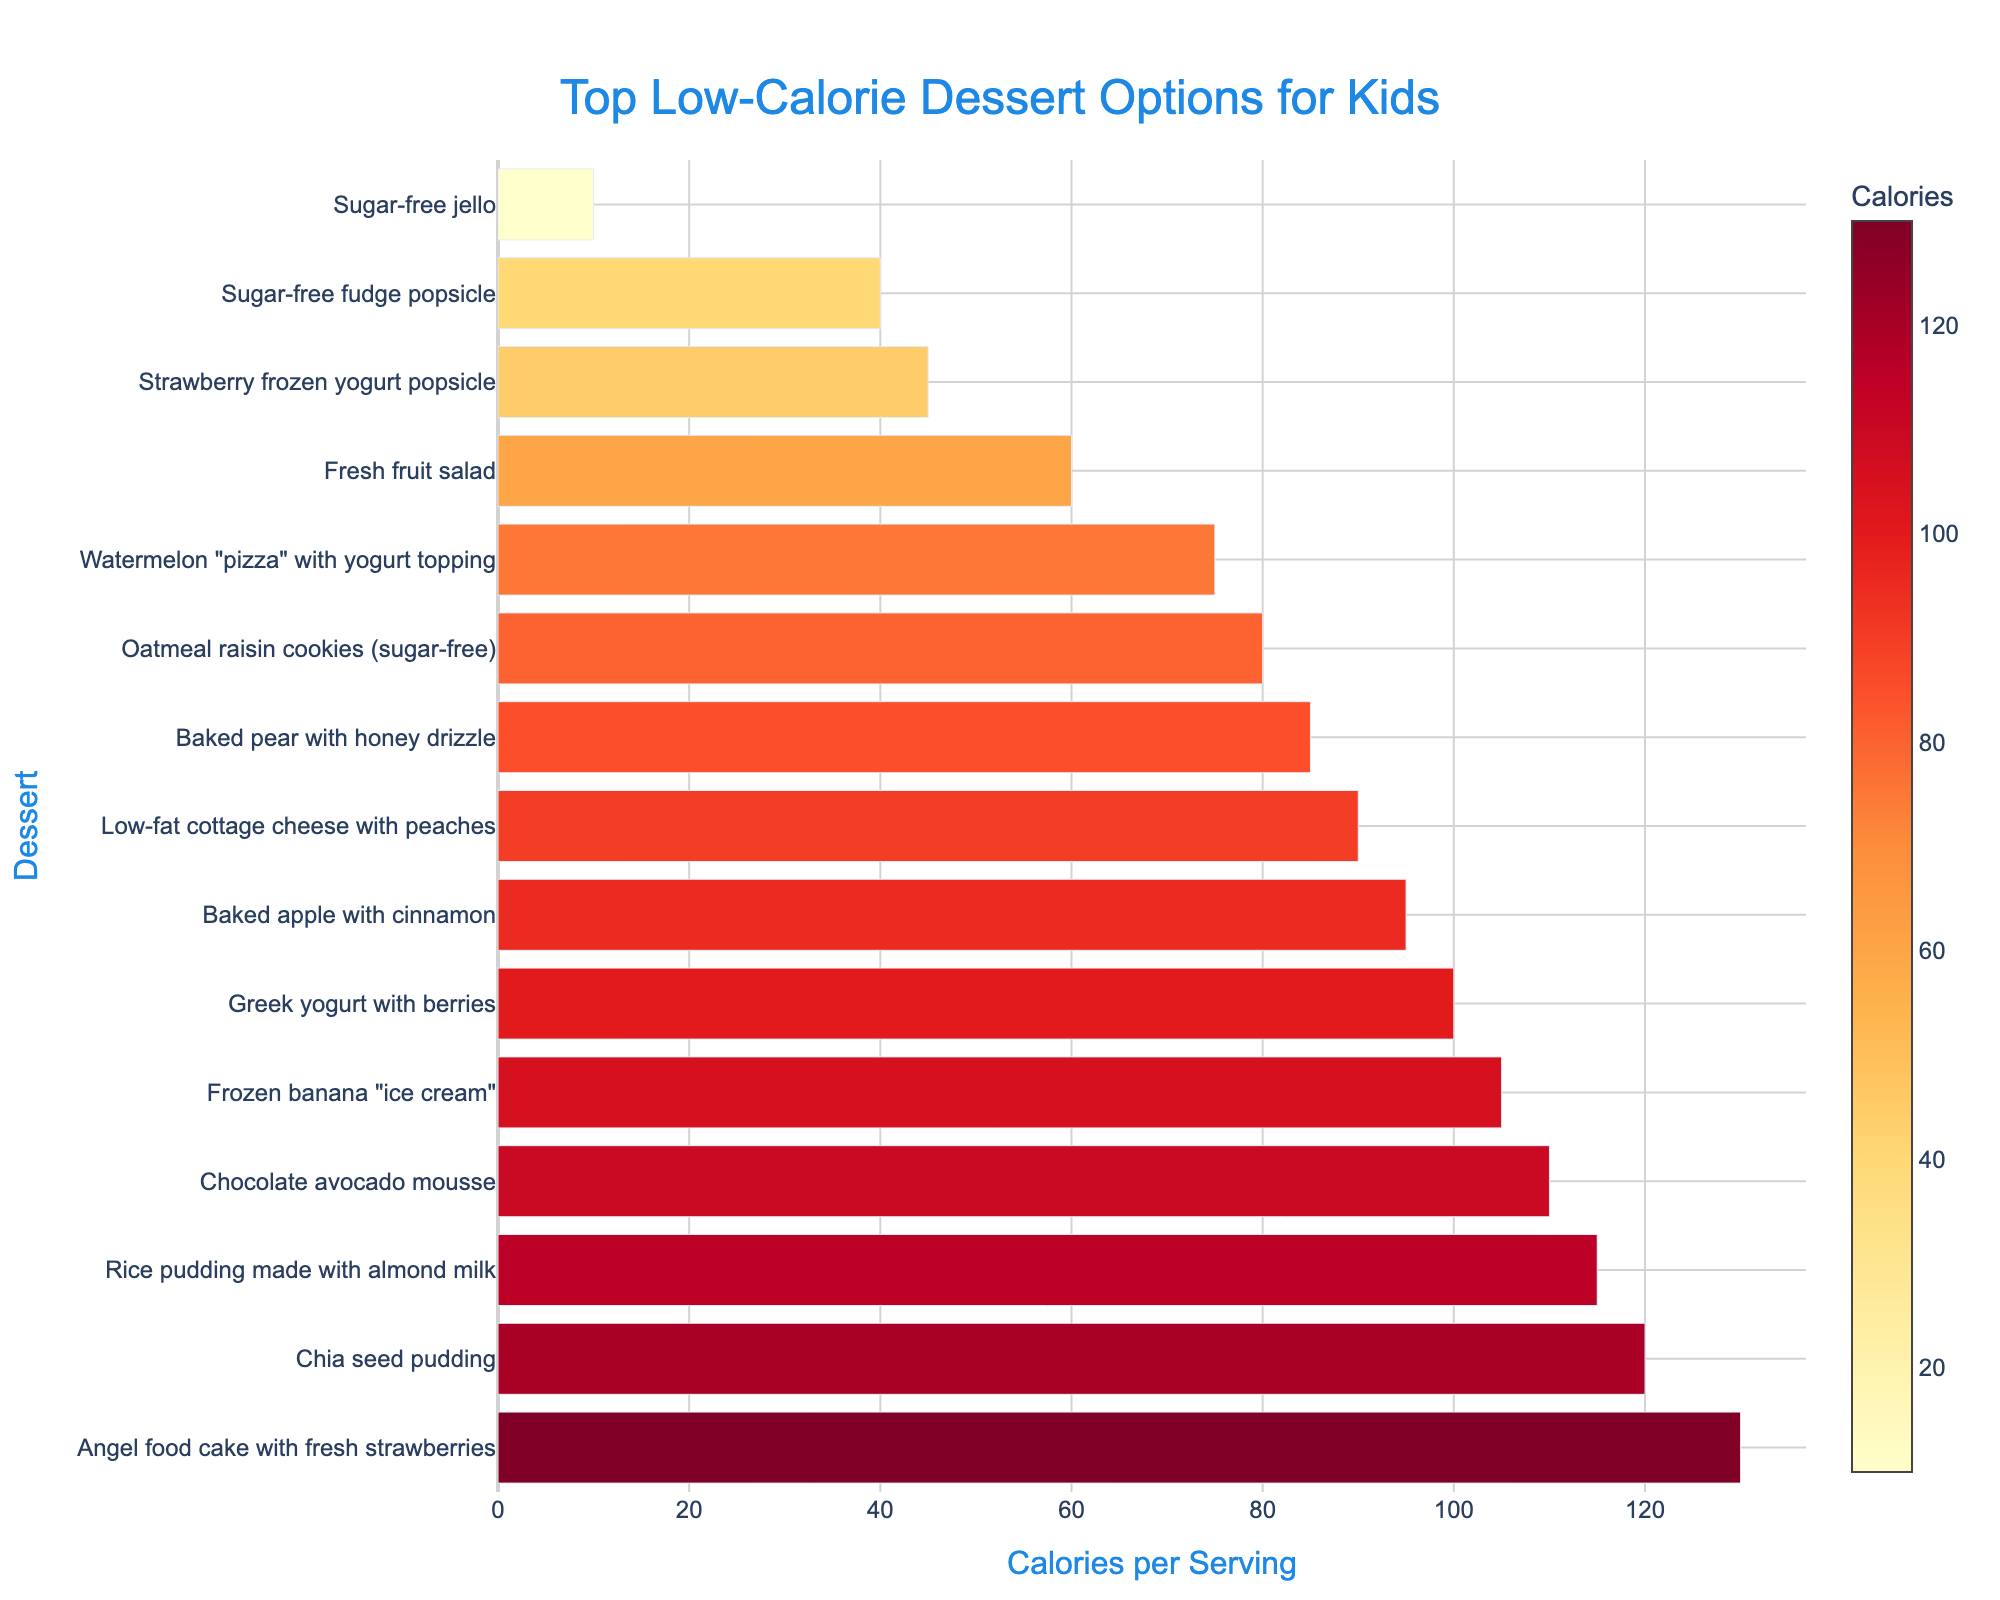What's the dessert with the highest calories per serving? Look for the dessert with the tallest bar, indicating the highest calorie count per serving. In the figure, Angel food cake with fresh strawberries has the highest calorie bar.
Answer: Angel food cake with fresh strawberries Which dessert has fewer calories, sugar-free jello or frozen banana "ice cream"? Compare the heights of the bars for sugar-free jello and frozen banana "ice cream." Sugar-free jello has a noticeably shorter bar, indicating fewer calories.
Answer: Sugar-free jello What is the difference in calories per serving between the dessert with the highest and the lowest calories? Identify the highest calorie dessert (Angel food cake with fresh strawberries at 130 calories) and the lowest calorie dessert (Sugar-free jello at 10 calories) and subtract the lower from the higher value: 130 - 10.
Answer: 120 calories Which is hotter in color on the color scale, Chia seed pudding or Baked pear with honey drizzle? Look at the color intensity of the bars for Chia seed pudding and Baked pear with honey drizzle. The bar for Chia seed pudding appears more toward the red end of the color scale, indicating higher color temperature.
Answer: Chia seed pudding How many desserts have fewer than 50 calories per serving? Count the number of bars that fall below the 50 calorie mark on the x-axis. These bars include Sugar-free jello, Strawberry frozen yogurt popsicle, and Sugar-free fudge popsicle.
Answer: 3 desserts What is the average calorie count of the five desserts with the lowest calories? Identify and sum the calories for the five lowest-calorie desserts: Sugar-free jello (10), Sugar-free fudge popsicle (40), Strawberry frozen yogurt popsicle (45), Watermelon "pizza" with yogurt topping (75), and Oatmeal raisin cookies (80), then divide by 5. Average = (10 + 40 + 45 + 75 + 80)/5.
Answer: 50 calories How many more calories does Chocolate avocado mousse have compared to Low-fat cottage cheese with peaches? Identify the calorie count for Chocolate avocado mousse (110) and Low-fat cottage cheese with peaches (90). Subtract the smaller value from the larger one: 110 - 90.
Answer: 20 calories Which dessert with fewer than 100 calories is visually the most intense color on the color bar? Look at desserts with bars indicating fewer than 100 calories. Among these, Frozen banana "ice cream" has the color bar most shifted toward the red color, implying the highest calorie intensity among this subset.
Answer: Frozen banana "ice cream" 